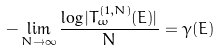<formula> <loc_0><loc_0><loc_500><loc_500>- \lim _ { N \rightarrow \infty } \frac { \log | T _ { \omega } ^ { ( 1 , N ) } ( E ) | } { N } = \gamma ( E )</formula> 